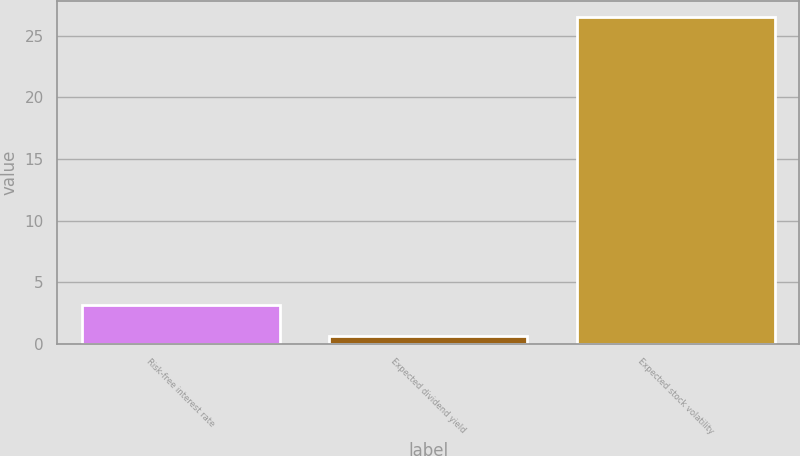<chart> <loc_0><loc_0><loc_500><loc_500><bar_chart><fcel>Risk-free interest rate<fcel>Expected dividend yield<fcel>Expected stock volatility<nl><fcel>3.19<fcel>0.6<fcel>26.5<nl></chart> 